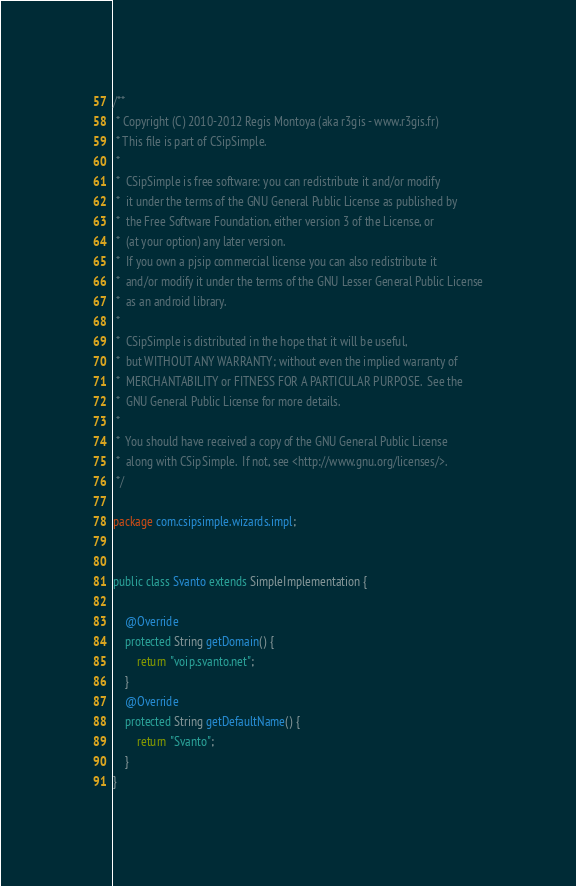Convert code to text. <code><loc_0><loc_0><loc_500><loc_500><_Java_>/**
 * Copyright (C) 2010-2012 Regis Montoya (aka r3gis - www.r3gis.fr)
 * This file is part of CSipSimple.
 *
 *  CSipSimple is free software: you can redistribute it and/or modify
 *  it under the terms of the GNU General Public License as published by
 *  the Free Software Foundation, either version 3 of the License, or
 *  (at your option) any later version.
 *  If you own a pjsip commercial license you can also redistribute it
 *  and/or modify it under the terms of the GNU Lesser General Public License
 *  as an android library.
 *
 *  CSipSimple is distributed in the hope that it will be useful,
 *  but WITHOUT ANY WARRANTY; without even the implied warranty of
 *  MERCHANTABILITY or FITNESS FOR A PARTICULAR PURPOSE.  See the
 *  GNU General Public License for more details.
 *
 *  You should have received a copy of the GNU General Public License
 *  along with CSipSimple.  If not, see <http://www.gnu.org/licenses/>.
 */

package com.csipsimple.wizards.impl;


public class Svanto extends SimpleImplementation {

	@Override
	protected String getDomain() {
		return "voip.svanto.net";
	}
	@Override
	protected String getDefaultName() {
		return "Svanto";
	}
}
</code> 